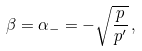Convert formula to latex. <formula><loc_0><loc_0><loc_500><loc_500>\beta = \alpha _ { - } = - \sqrt { \frac { p } { p ^ { \prime } } } \, ,</formula> 